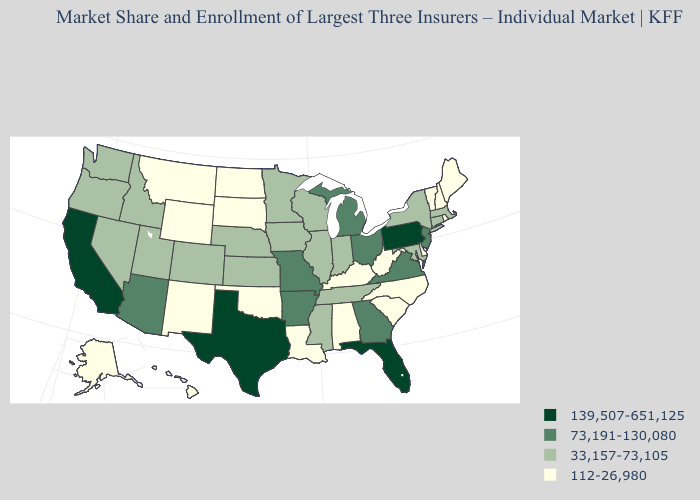Name the states that have a value in the range 112-26,980?
Concise answer only. Alabama, Alaska, Delaware, Hawaii, Kentucky, Louisiana, Maine, Montana, New Hampshire, New Mexico, North Carolina, North Dakota, Oklahoma, Rhode Island, South Carolina, South Dakota, Vermont, West Virginia, Wyoming. Among the states that border Mississippi , which have the lowest value?
Concise answer only. Alabama, Louisiana. What is the lowest value in the USA?
Give a very brief answer. 112-26,980. Does Florida have the lowest value in the USA?
Write a very short answer. No. Is the legend a continuous bar?
Give a very brief answer. No. What is the value of Wisconsin?
Quick response, please. 33,157-73,105. Among the states that border Missouri , which have the highest value?
Concise answer only. Arkansas. Does the map have missing data?
Be succinct. No. What is the value of Maryland?
Quick response, please. 33,157-73,105. Among the states that border South Dakota , does Wyoming have the lowest value?
Write a very short answer. Yes. Name the states that have a value in the range 139,507-651,125?
Concise answer only. California, Florida, Pennsylvania, Texas. What is the value of Delaware?
Give a very brief answer. 112-26,980. Does Colorado have the lowest value in the West?
Short answer required. No. Which states hav the highest value in the MidWest?
Write a very short answer. Michigan, Missouri, Ohio. Does the first symbol in the legend represent the smallest category?
Keep it brief. No. 